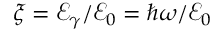<formula> <loc_0><loc_0><loc_500><loc_500>\xi = \mathcal { E } _ { \gamma } / \mathcal { E } _ { 0 } = \hbar { \omega } / \mathcal { E } _ { 0 }</formula> 